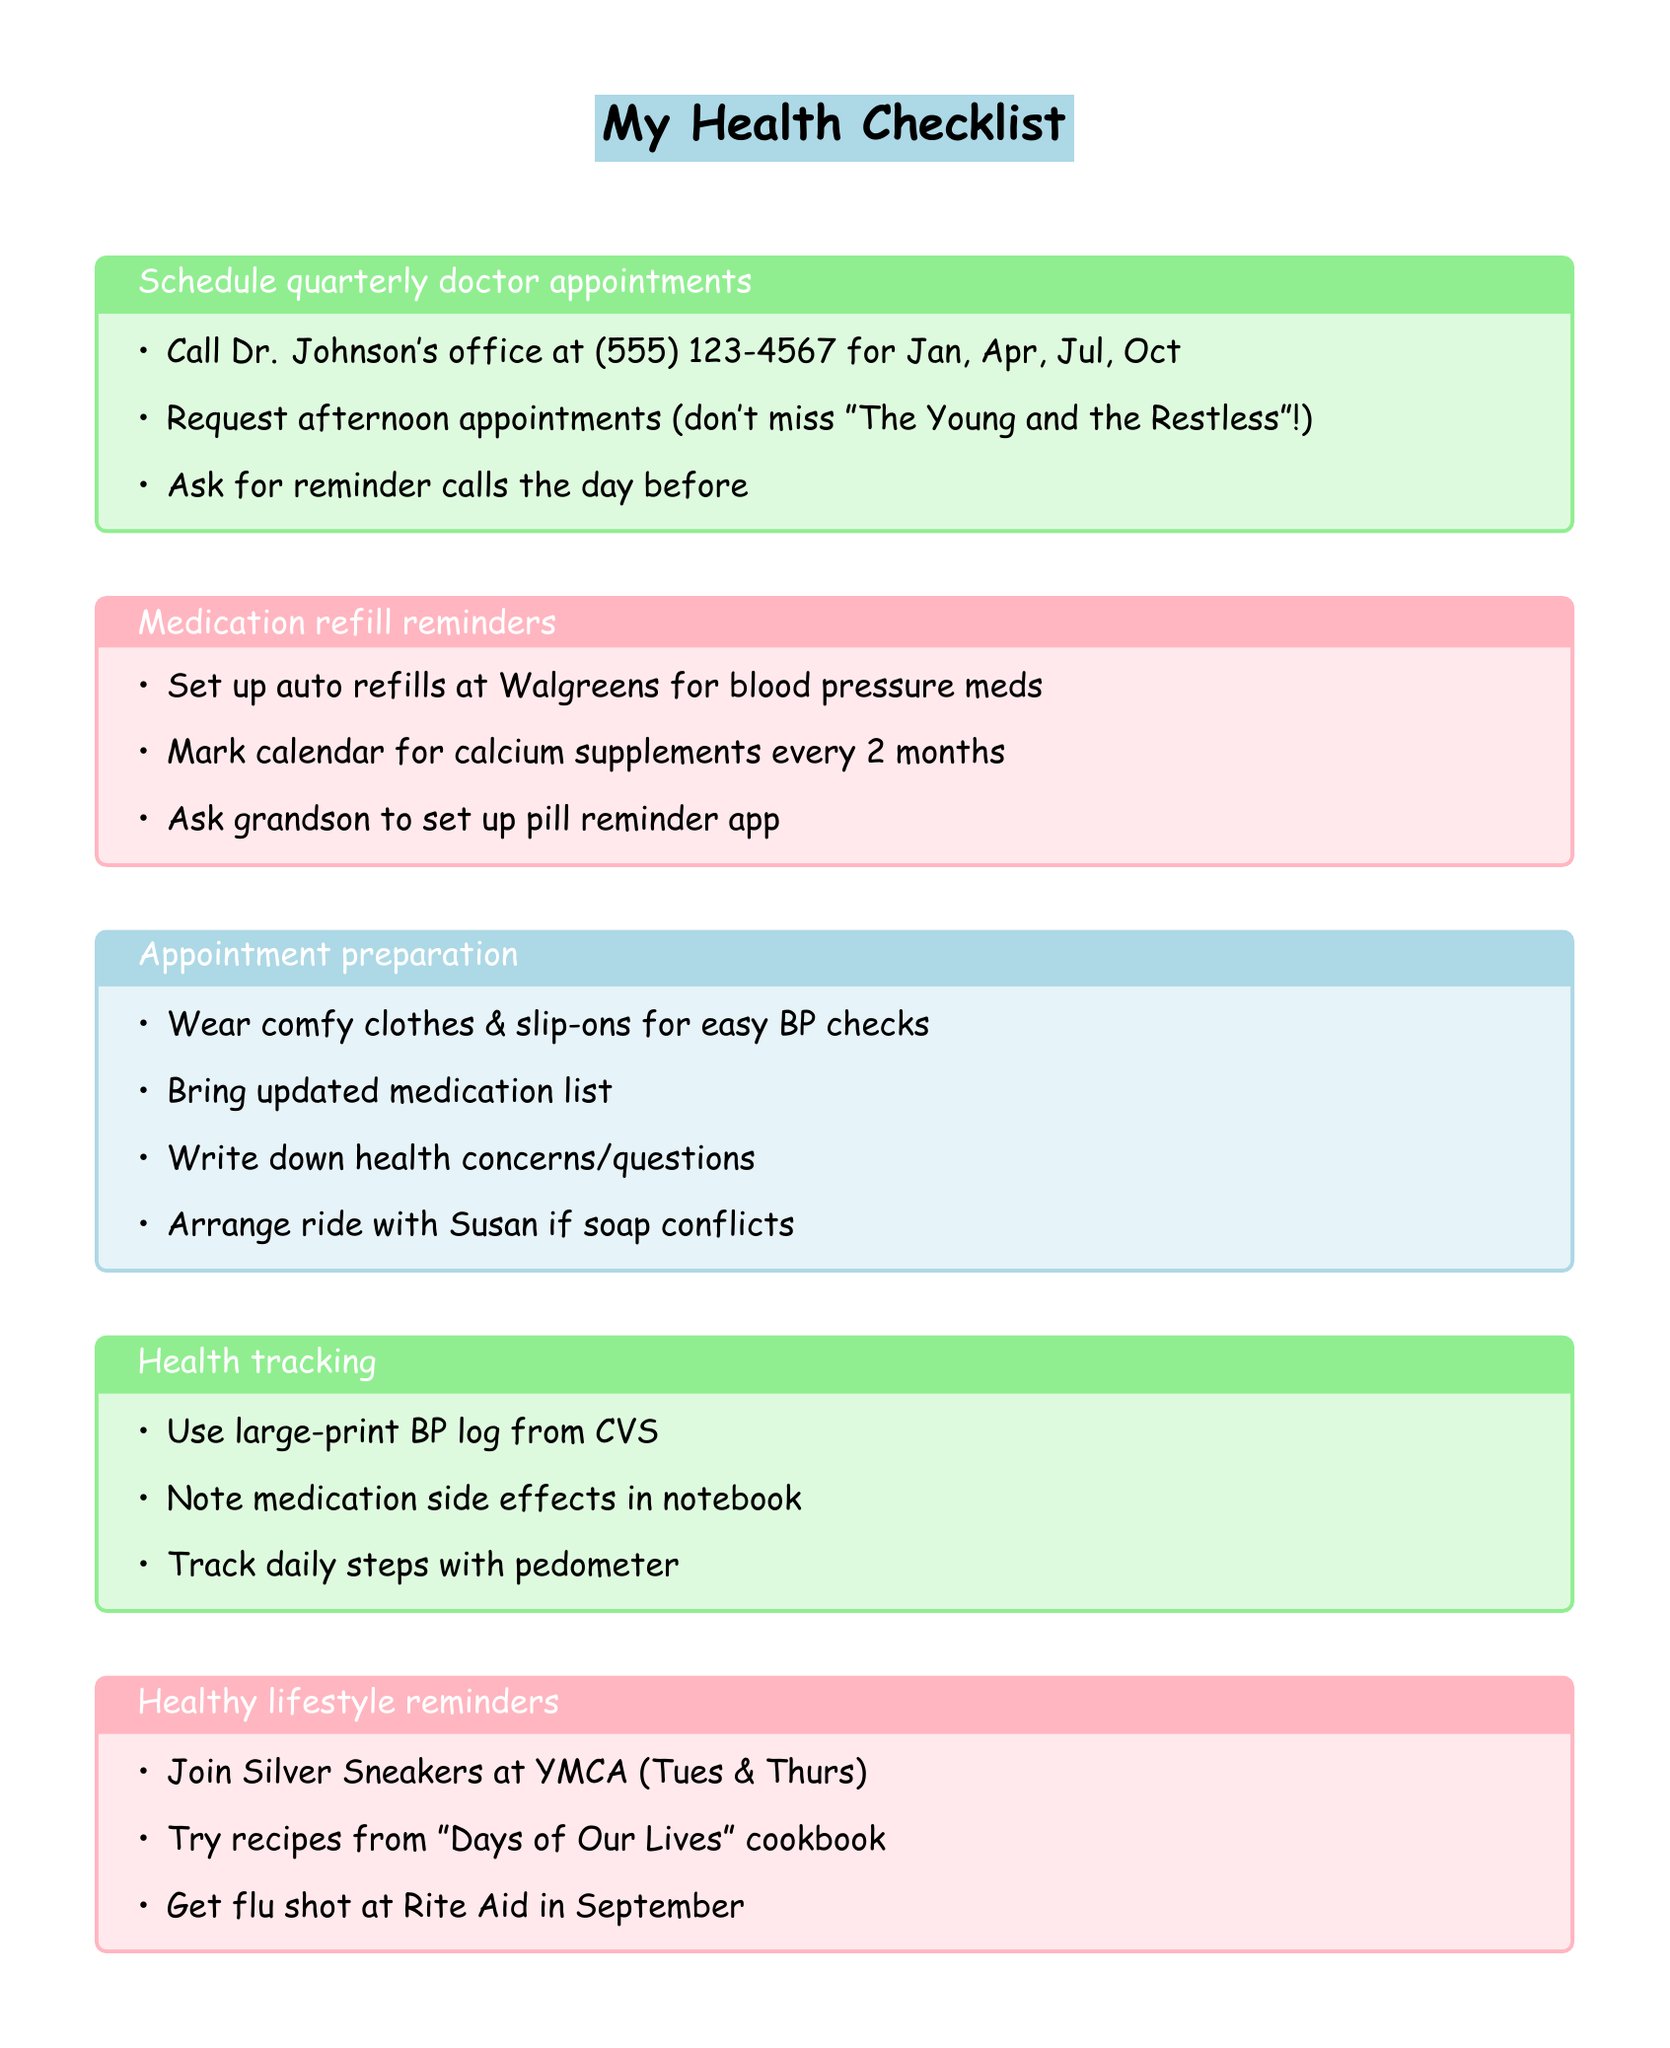What is the name of the doctor? The document mentions Dr. Johnson as the doctor to schedule appointments with.
Answer: Dr. Johnson How many quarterly appointments should be scheduled? The document specifies appointments for January, April, July, and October, which totals four.
Answer: Four What medication is set up for auto refills? The document states the blood pressure medication to be set up for automatic refills is Lisinopril.
Answer: Lisinopril How often should calcium supplements be refilled? The document instructs to mark the calendar for refilling calcium supplements every two months.
Answer: Every two months What should be worn for easy blood pressure checks? The document recommends wearing comfortable clothing and slip-on shoes for convenient blood pressure checks.
Answer: Comfortable clothing and slip-on shoes What transportation arrangement is suggested in case of a soap opera conflict? The document suggests arranging transportation with neighbor Susan if there is a conflict in the soap opera schedule.
Answer: Neighbor Susan What health tracking tool is recommended for blood pressure? The document mentions using a large-print blood pressure log from CVS to record daily readings.
Answer: Large-print blood pressure log On which days should the Silver Sneakers exercise class be attended? The document specifies attending the Silver Sneakers class at the YMCA on Tuesdays and Thursdays.
Answer: Tuesdays and Thursdays What action should be taken for medication side effects? The document advises noting any side effects from medications in a dedicated notebook.
Answer: Note in a dedicated notebook 